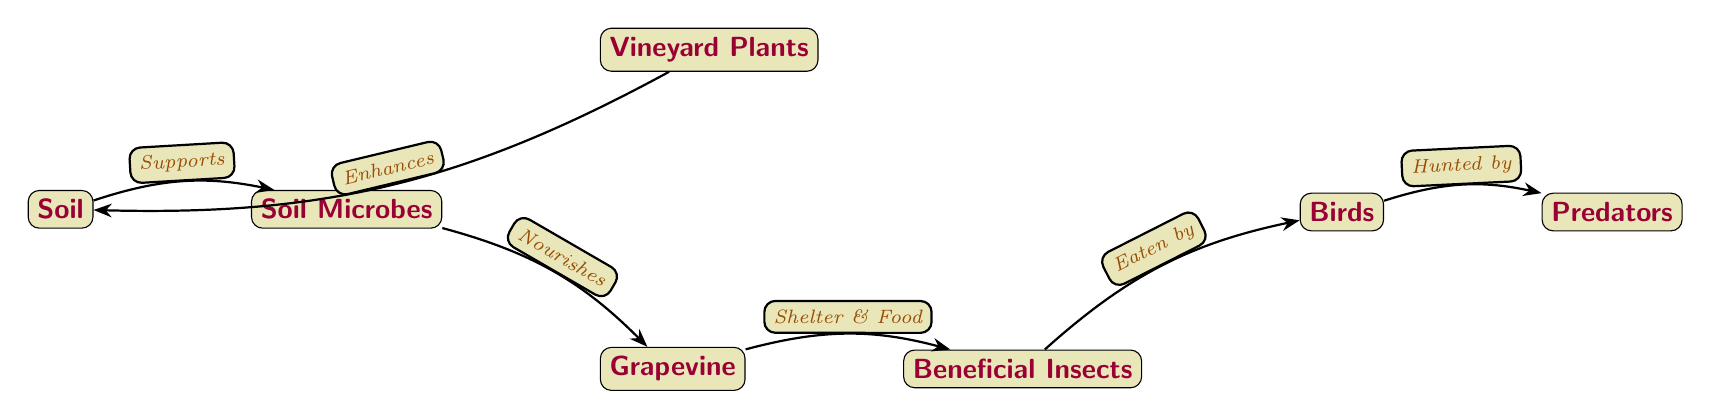What is the first node in the diagram? The first node, or starting point, in the diagram is "Soil." It is positioned at the leftmost part of the diagram, indicating it as the foundational element of the food chain.
Answer: Soil How many total nodes are there in the diagram? By counting each node presented in the diagram, we identify the following nodes: Soil, Soil Microbes, Vineyard Plants, Grapevine, Beneficial Insects, Birds, and Predators, which totals to seven nodes.
Answer: 7 What relationship describes the flow from Soil to Soil Microbes? The relationship between Soil and Soil Microbes is described as "Supports," indicating that soil provides necessary conditions for microbes to thrive. This connection illustrates the vital role of soil in supporting microbial life.
Answer: Supports Which node provides shelter and food for Beneficial Insects? The "Grapevine" node provides both shelter and food for the Beneficial Insects. This indicates the importance of grapevines in creating a habitat that supports insect life.
Answer: Grapevine What do Birds eat according to the diagram? Birds eat "Beneficial Insects" as indicated by the connection in the diagram, highlighting the predator-prey relationship that plays a role in pest management within the vineyard ecosystem.
Answer: Beneficial Insects What type of relationship does Vineyard Plants have with Soil? The relationship is described as "Enhances." This indicates that vineyard plants contribute positively to the quality or structure of the soil, signifying an interdependent relationship.
Answer: Enhances Who is at the top of the food chain in this diagram? "Predators" are positioned at the top of the food chain, indicating that they are the ultimate consumers within this ecological structure, relying on the lower levels for their food supply.
Answer: Predators How do Soil Microbes interact with Grapevine according to this diagram? Soil Microbes "Nourish" the Grapevine, suggesting that the health of the grapevine is directly linked to the activity and presence of soil microbes in the system.
Answer: Nourishes What role do Birds play in this food chain? Birds are depicted as "Hunted by" Predators, indicating their role as consumers of Beneficial Insects and as prey for higher-order consumers, showcasing their dual position in the food chain.
Answer: Hunted by 